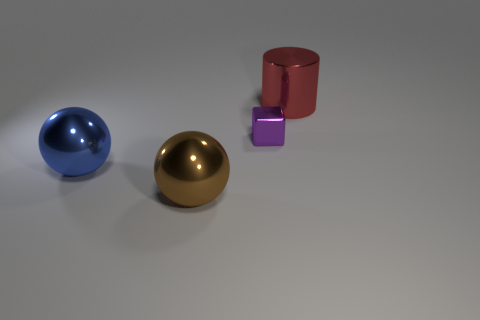Add 4 big cylinders. How many objects exist? 8 Subtract all blocks. How many objects are left? 3 Add 4 brown spheres. How many brown spheres are left? 5 Add 3 tiny purple metal things. How many tiny purple metal things exist? 4 Subtract 1 purple cubes. How many objects are left? 3 Subtract all large metallic balls. Subtract all blue objects. How many objects are left? 1 